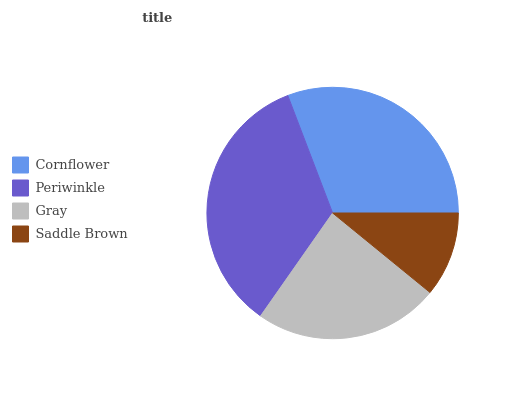Is Saddle Brown the minimum?
Answer yes or no. Yes. Is Periwinkle the maximum?
Answer yes or no. Yes. Is Gray the minimum?
Answer yes or no. No. Is Gray the maximum?
Answer yes or no. No. Is Periwinkle greater than Gray?
Answer yes or no. Yes. Is Gray less than Periwinkle?
Answer yes or no. Yes. Is Gray greater than Periwinkle?
Answer yes or no. No. Is Periwinkle less than Gray?
Answer yes or no. No. Is Cornflower the high median?
Answer yes or no. Yes. Is Gray the low median?
Answer yes or no. Yes. Is Saddle Brown the high median?
Answer yes or no. No. Is Periwinkle the low median?
Answer yes or no. No. 